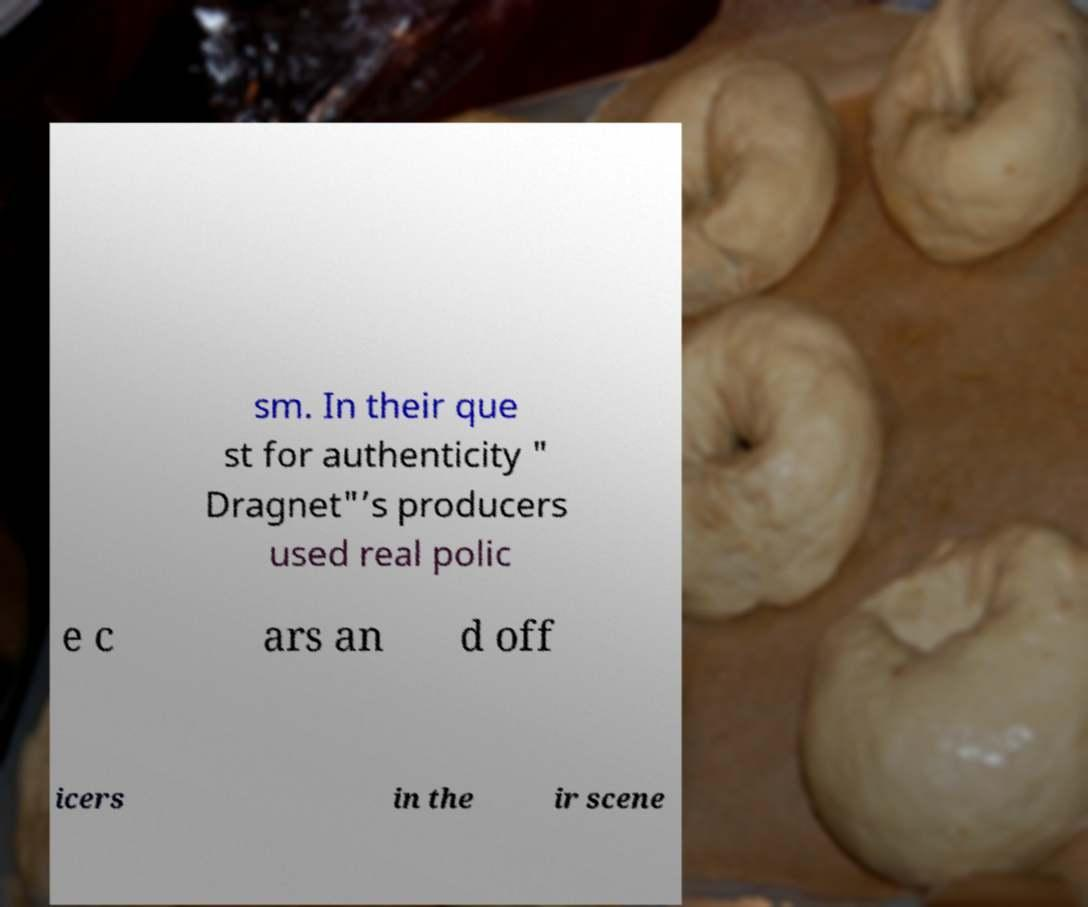What messages or text are displayed in this image? I need them in a readable, typed format. sm. In their que st for authenticity " Dragnet"’s producers used real polic e c ars an d off icers in the ir scene 